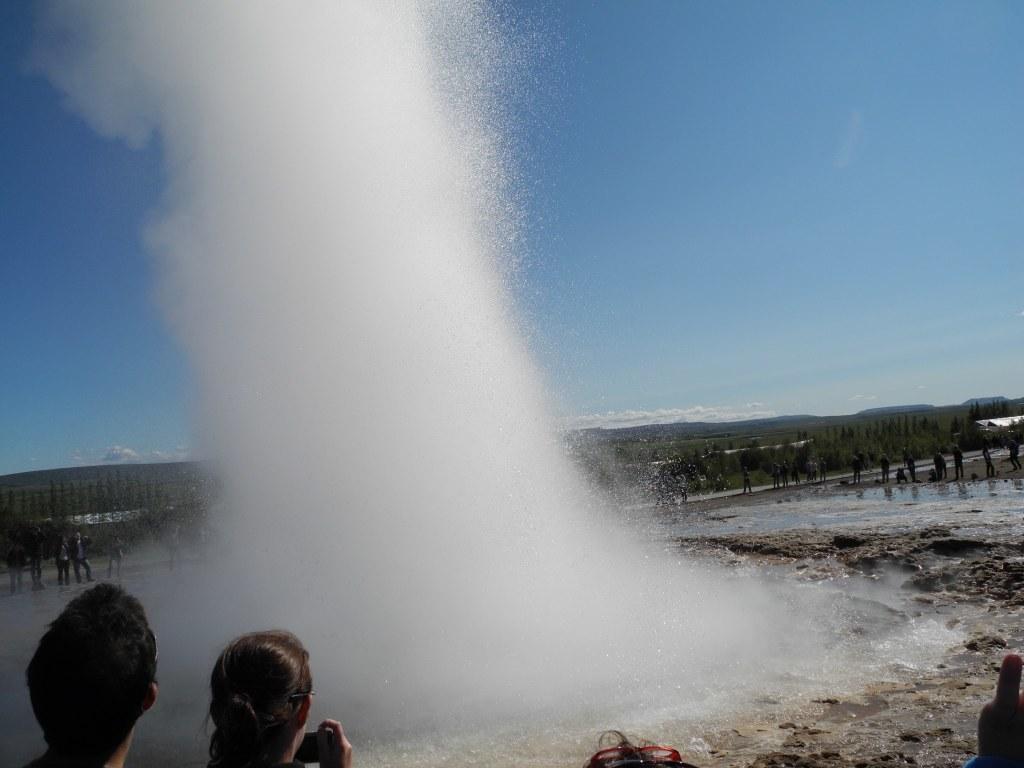Can you describe this image briefly? At the center of the image we can see there is a water explosion, around that there are a few people standing and few are taking pictures of it with the camera. In the background there are trees, mountains and the sky. 